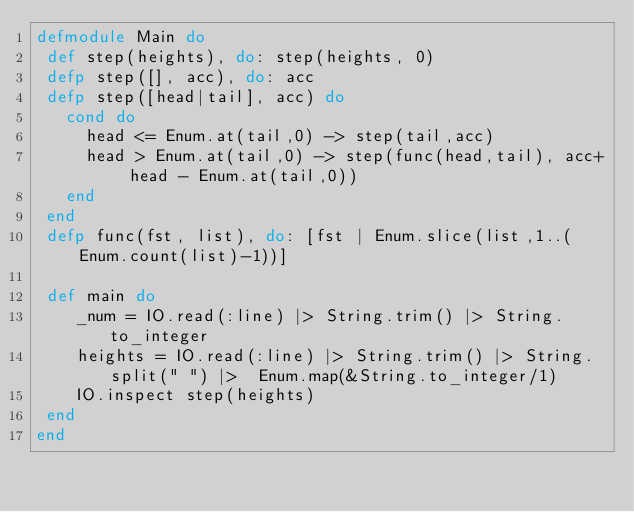<code> <loc_0><loc_0><loc_500><loc_500><_Elixir_>defmodule Main do
 def step(heights), do: step(heights, 0)
 defp step([], acc), do: acc
 defp step([head|tail], acc) do
   cond do
     head <= Enum.at(tail,0) -> step(tail,acc)
     head > Enum.at(tail,0) -> step(func(head,tail), acc+ head - Enum.at(tail,0))
   end
 end
 defp func(fst, list), do: [fst | Enum.slice(list,1..(Enum.count(list)-1))]
 
 def main do
    _num = IO.read(:line) |> String.trim() |> String.to_integer
    heights = IO.read(:line) |> String.trim() |> String.split(" ") |>  Enum.map(&String.to_integer/1)
    IO.inspect step(heights)
 end
end</code> 